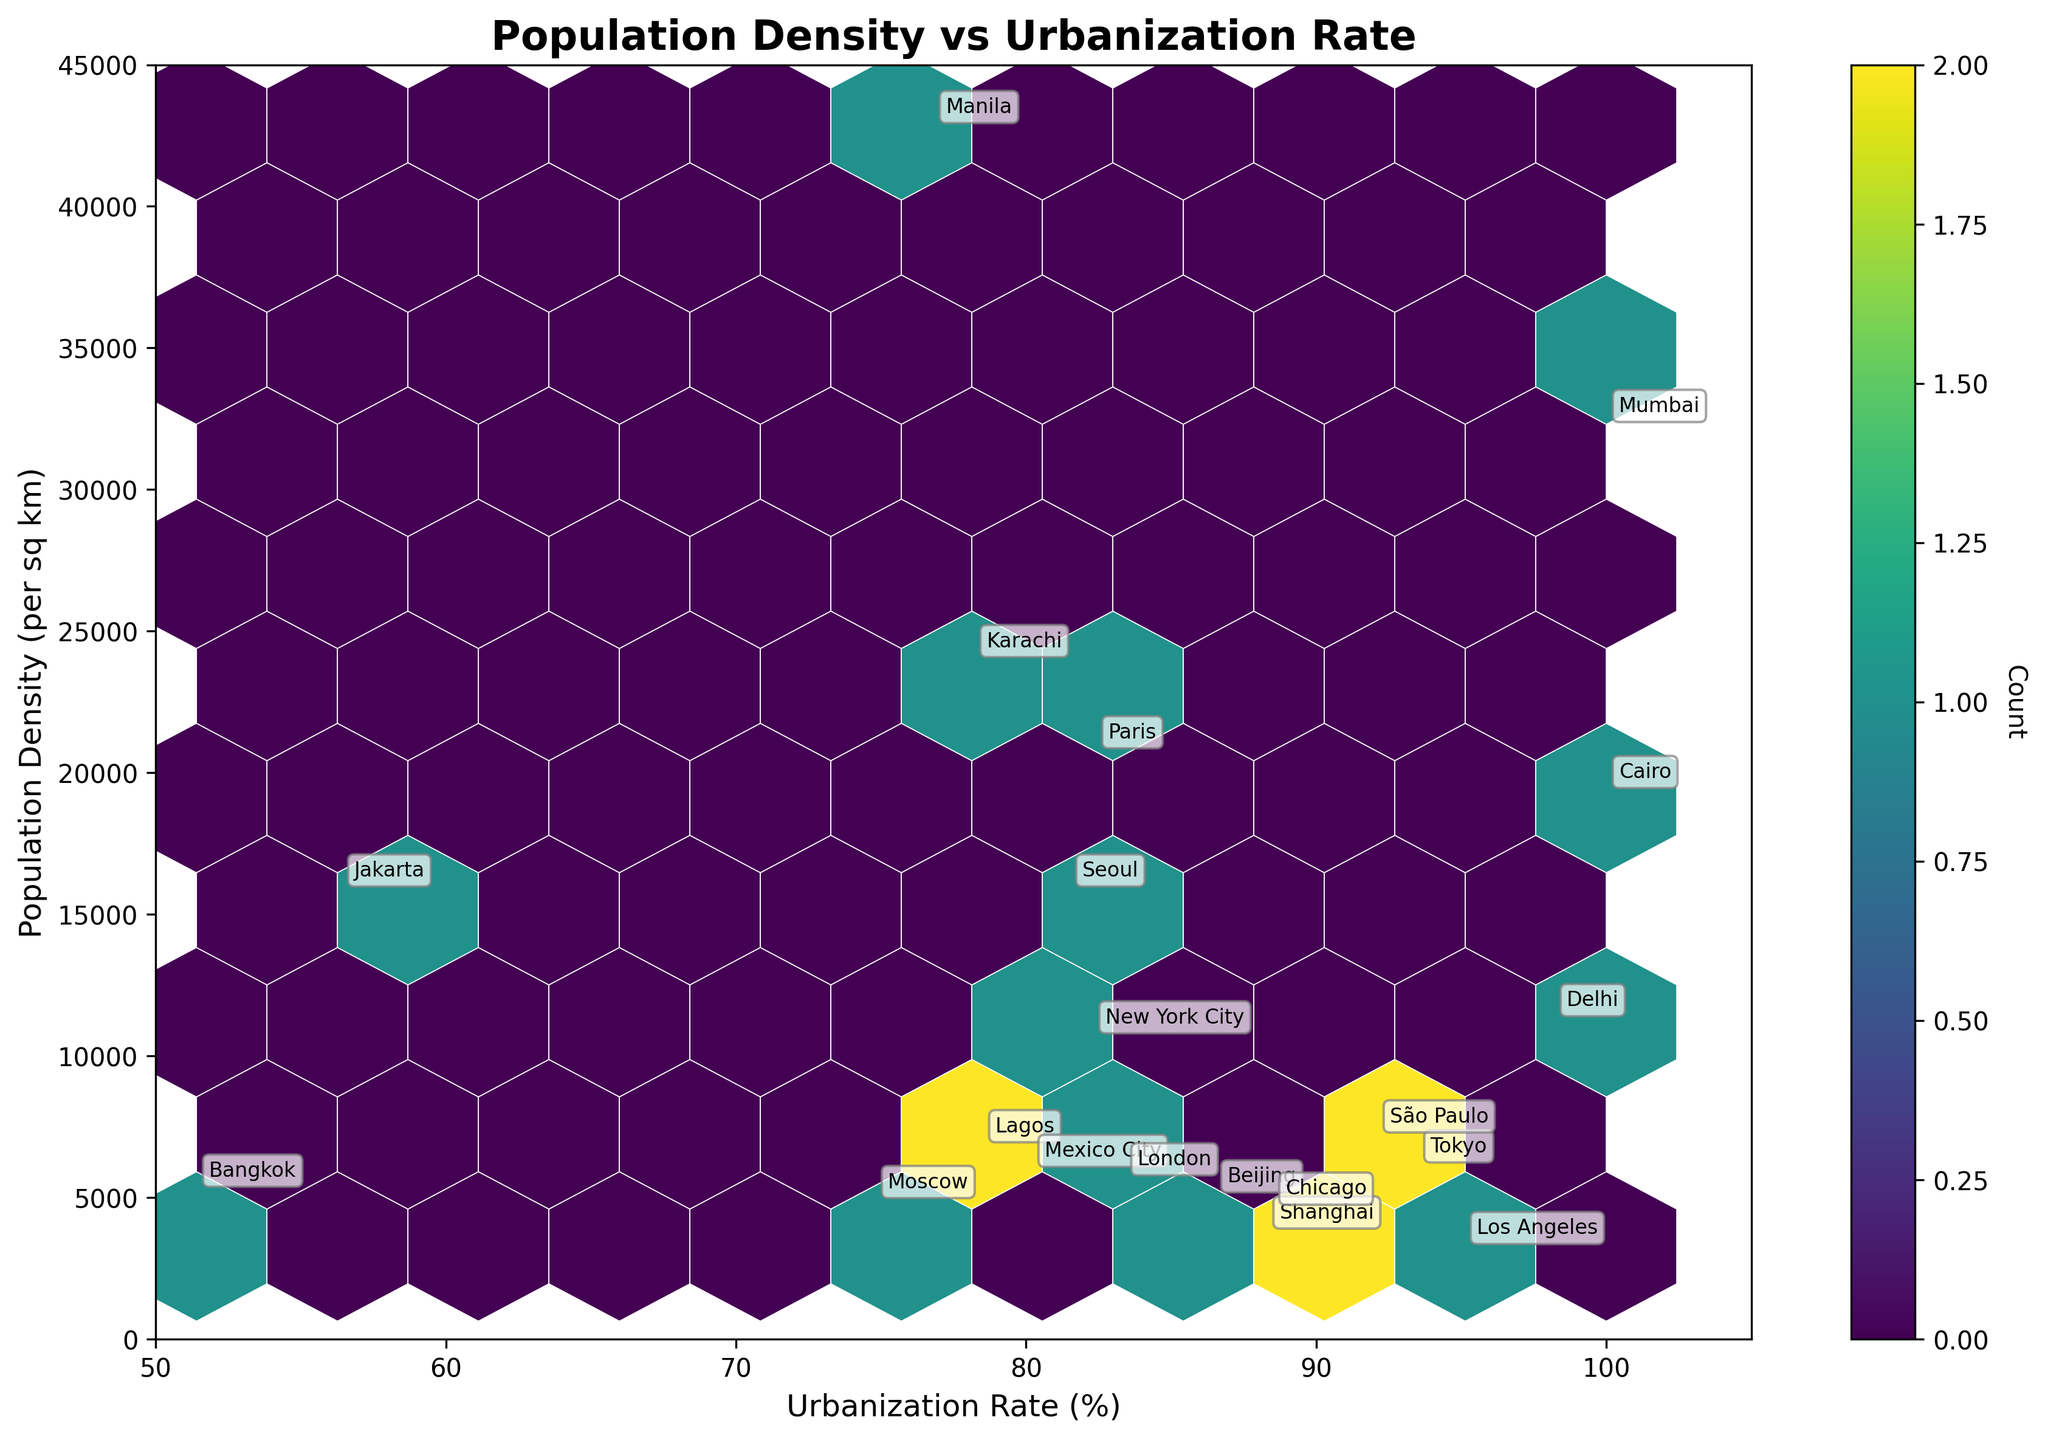What is the title of the plot? The title is usually at the top of the figure. In this case, look at the top to find the text indicating the title of the plot.
Answer: Population Density vs Urbanization Rate What color scheme is used for the hexbin plot? The color scheme or colormap used is typically indicated by the colors shown in the plot. Here, the hexbin plot uses shades of green from dark to light.
Answer: viridis How many data points are used in the plot? The number of data points corresponds to the number of cities listed, as each city is represented by one data point. Count the rows in the data table provided.
Answer: 20 What is the population density of the city with the highest density? Scan the vertical axis (Population Density) to find the highest value marked on the plot, which corresponds to Manila. Then, look up Manila's population density in the data.
Answer: 42857 Which city has the lowest urbanization rate? Scan the horizontal axis (Urbanization Rate) for the lowest value marked and then look at the corresponding city listed near this value.
Answer: Bangkok Which cities have an urbanization rate of 100%? Identify the marks on the horizontal axis for 100% and find the cities annotated near this mark.
Answer: Mumbai and Cairo Compare the population density of Tokyo and Lagos. Which city is denser? Locate Tokyo and Lagos on the plot by their urbanization rates and then compare their vertical positions. The city higher on the plot has a higher density.
Answer: Lagos What is the urbanization rate range that has the highest population density concentration? Observe the density of the hexagons and their colors along the urbanization rate axis to identify where the most hexagons are clustered.
Answer: 75% to 95% Which city has the closest population density to 10,000 persons per sq km? Look at the vertical axis for 10,000, find the nearest annotated city, and verify its population density in the data table.
Answer: New York City What regions of the plot show the greatest concentration of urbanization rates and population densities? Look across the plot to see where the hexbin hexagons are darkest, indicating the highest concentration.
Answer: 75% to 95% urbanization rate, 6000 to 24,000 density 